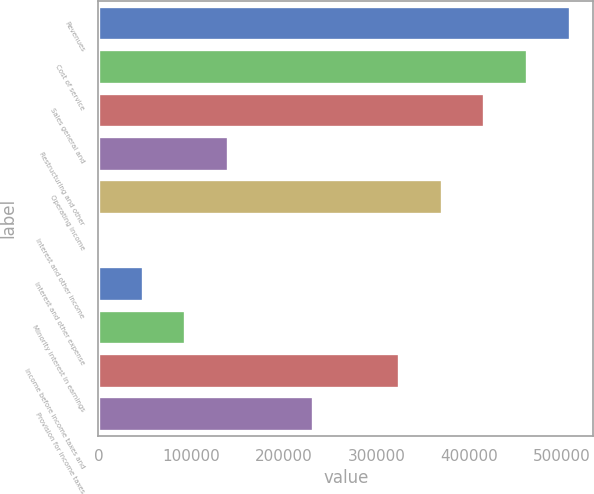Convert chart. <chart><loc_0><loc_0><loc_500><loc_500><bar_chart><fcel>Revenues<fcel>Cost of service<fcel>Sales general and<fcel>Restructuring and other<fcel>Operating income<fcel>Interest and other income<fcel>Interest and other expense<fcel>Minority interest in earnings<fcel>Income before income taxes and<fcel>Provision for income taxes<nl><fcel>508949<fcel>462826<fcel>416703<fcel>139968<fcel>370581<fcel>1600<fcel>47722.6<fcel>93845.2<fcel>324458<fcel>232213<nl></chart> 